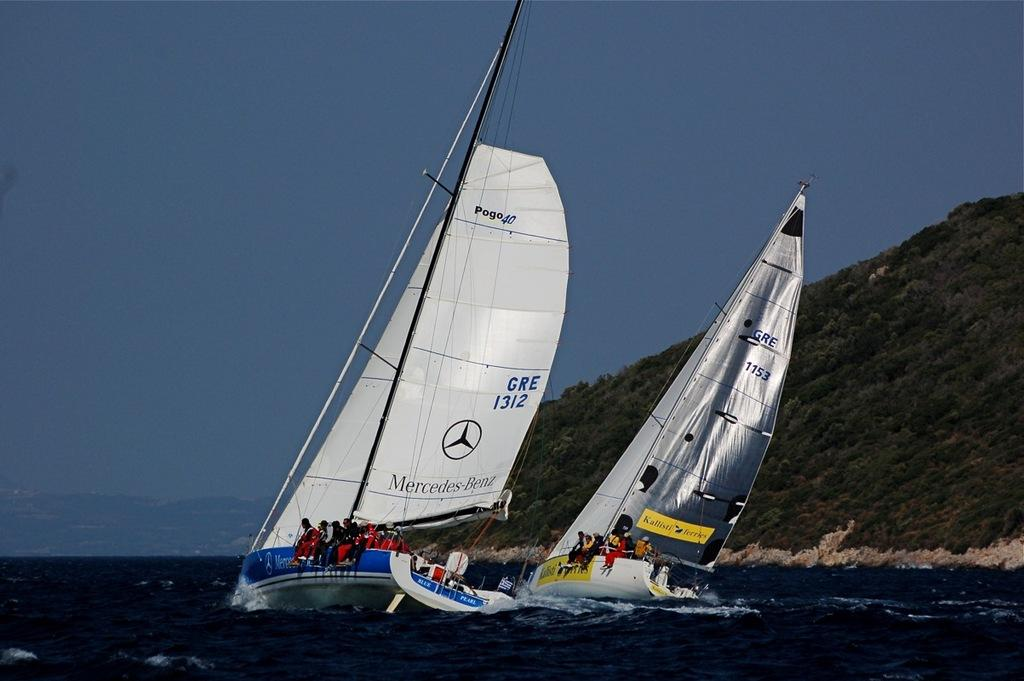Provide a one-sentence caption for the provided image. A boat with a sail that says Mercedez Benz on it. 